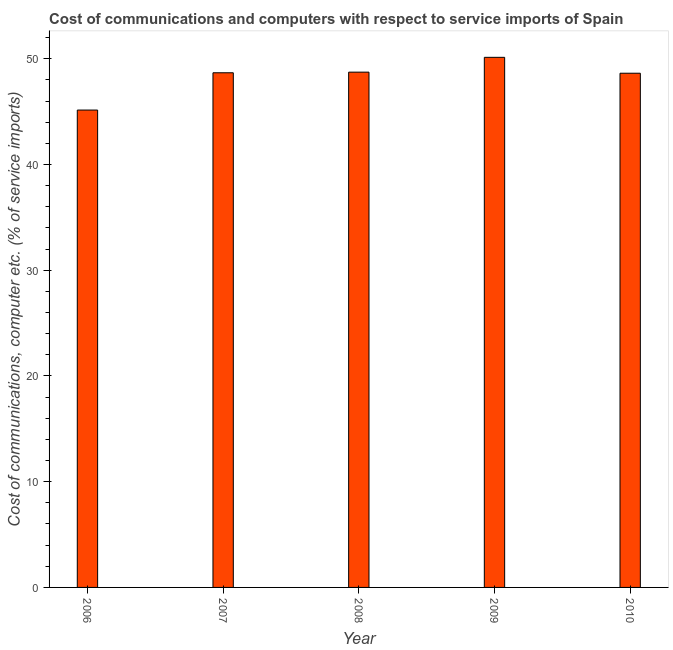Does the graph contain any zero values?
Your answer should be very brief. No. Does the graph contain grids?
Your response must be concise. No. What is the title of the graph?
Provide a short and direct response. Cost of communications and computers with respect to service imports of Spain. What is the label or title of the X-axis?
Ensure brevity in your answer.  Year. What is the label or title of the Y-axis?
Offer a very short reply. Cost of communications, computer etc. (% of service imports). What is the cost of communications and computer in 2006?
Ensure brevity in your answer.  45.14. Across all years, what is the maximum cost of communications and computer?
Provide a short and direct response. 50.13. Across all years, what is the minimum cost of communications and computer?
Your response must be concise. 45.14. In which year was the cost of communications and computer maximum?
Your answer should be compact. 2009. In which year was the cost of communications and computer minimum?
Keep it short and to the point. 2006. What is the sum of the cost of communications and computer?
Give a very brief answer. 241.3. What is the difference between the cost of communications and computer in 2007 and 2009?
Provide a succinct answer. -1.46. What is the average cost of communications and computer per year?
Provide a succinct answer. 48.26. What is the median cost of communications and computer?
Keep it short and to the point. 48.67. Do a majority of the years between 2009 and 2006 (inclusive) have cost of communications and computer greater than 50 %?
Ensure brevity in your answer.  Yes. Is the difference between the cost of communications and computer in 2006 and 2008 greater than the difference between any two years?
Keep it short and to the point. No. What is the difference between the highest and the second highest cost of communications and computer?
Provide a succinct answer. 1.4. What is the difference between the highest and the lowest cost of communications and computer?
Your response must be concise. 4.99. Are all the bars in the graph horizontal?
Make the answer very short. No. How many years are there in the graph?
Your response must be concise. 5. What is the Cost of communications, computer etc. (% of service imports) in 2006?
Make the answer very short. 45.14. What is the Cost of communications, computer etc. (% of service imports) in 2007?
Offer a terse response. 48.67. What is the Cost of communications, computer etc. (% of service imports) in 2008?
Provide a succinct answer. 48.73. What is the Cost of communications, computer etc. (% of service imports) in 2009?
Your answer should be very brief. 50.13. What is the Cost of communications, computer etc. (% of service imports) of 2010?
Provide a short and direct response. 48.63. What is the difference between the Cost of communications, computer etc. (% of service imports) in 2006 and 2007?
Your answer should be compact. -3.53. What is the difference between the Cost of communications, computer etc. (% of service imports) in 2006 and 2008?
Keep it short and to the point. -3.58. What is the difference between the Cost of communications, computer etc. (% of service imports) in 2006 and 2009?
Offer a very short reply. -4.99. What is the difference between the Cost of communications, computer etc. (% of service imports) in 2006 and 2010?
Your response must be concise. -3.48. What is the difference between the Cost of communications, computer etc. (% of service imports) in 2007 and 2008?
Keep it short and to the point. -0.06. What is the difference between the Cost of communications, computer etc. (% of service imports) in 2007 and 2009?
Make the answer very short. -1.46. What is the difference between the Cost of communications, computer etc. (% of service imports) in 2007 and 2010?
Keep it short and to the point. 0.04. What is the difference between the Cost of communications, computer etc. (% of service imports) in 2008 and 2009?
Provide a succinct answer. -1.4. What is the difference between the Cost of communications, computer etc. (% of service imports) in 2008 and 2010?
Give a very brief answer. 0.1. What is the difference between the Cost of communications, computer etc. (% of service imports) in 2009 and 2010?
Ensure brevity in your answer.  1.5. What is the ratio of the Cost of communications, computer etc. (% of service imports) in 2006 to that in 2007?
Give a very brief answer. 0.93. What is the ratio of the Cost of communications, computer etc. (% of service imports) in 2006 to that in 2008?
Make the answer very short. 0.93. What is the ratio of the Cost of communications, computer etc. (% of service imports) in 2006 to that in 2009?
Your response must be concise. 0.9. What is the ratio of the Cost of communications, computer etc. (% of service imports) in 2006 to that in 2010?
Make the answer very short. 0.93. What is the ratio of the Cost of communications, computer etc. (% of service imports) in 2007 to that in 2010?
Keep it short and to the point. 1. What is the ratio of the Cost of communications, computer etc. (% of service imports) in 2008 to that in 2009?
Offer a terse response. 0.97. What is the ratio of the Cost of communications, computer etc. (% of service imports) in 2009 to that in 2010?
Your answer should be very brief. 1.03. 